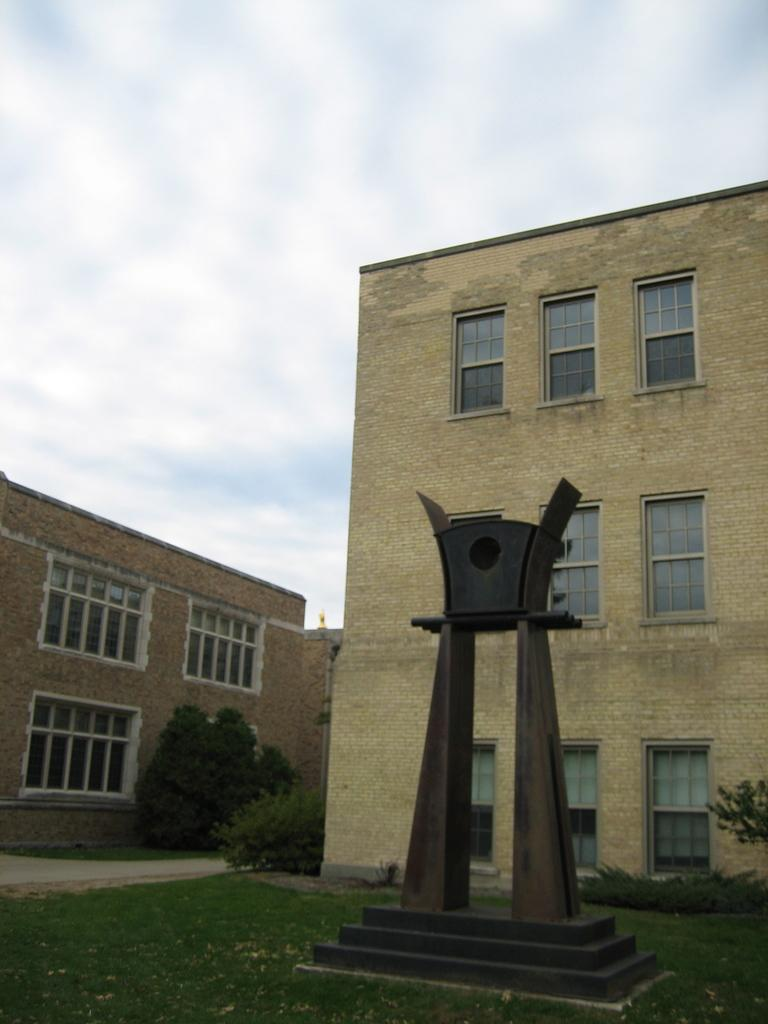What is the main subject in the image? There is a sculpture in the image. What other structures can be seen in the image? There are buildings in the image. What type of vegetation is present in the image? There are trees in the image. What is at the bottom of the image? There is grass at the bottom of the image. What can be seen in the background of the image? The sky is visible in the background of the image. Can you see any powder on the sculpture in the image? There is no mention of powder in the image, so it cannot be determined if there is any powder present. 